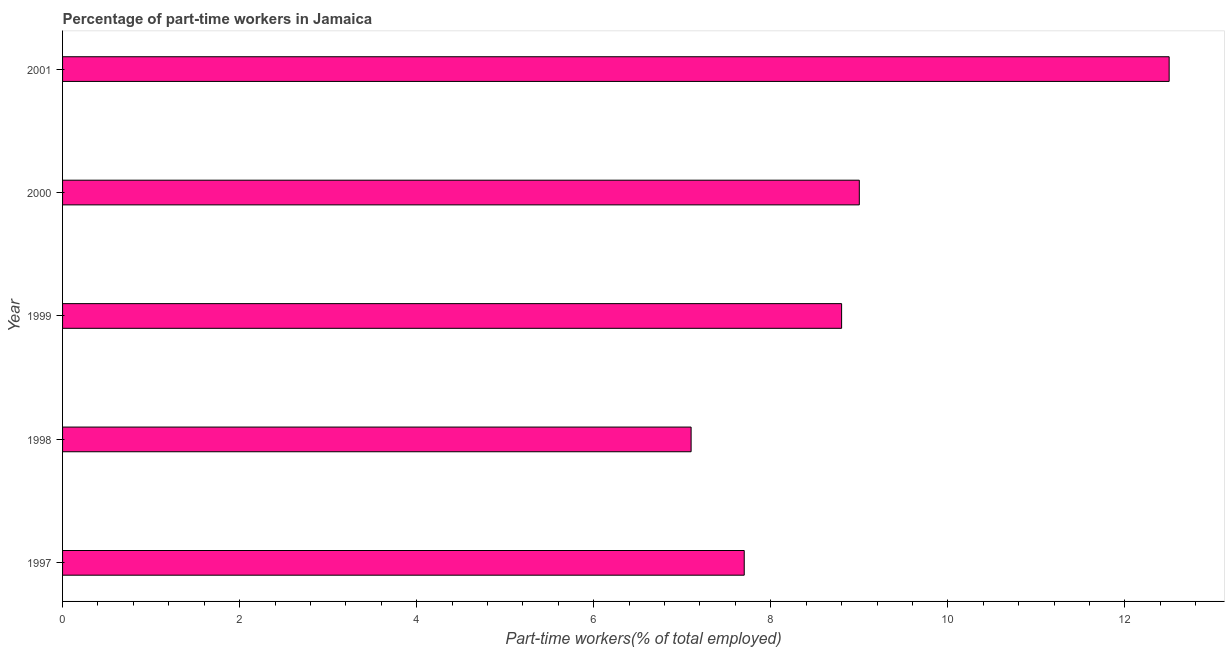Does the graph contain grids?
Your answer should be very brief. No. What is the title of the graph?
Make the answer very short. Percentage of part-time workers in Jamaica. What is the label or title of the X-axis?
Offer a terse response. Part-time workers(% of total employed). What is the label or title of the Y-axis?
Your answer should be very brief. Year. What is the percentage of part-time workers in 1998?
Give a very brief answer. 7.1. Across all years, what is the maximum percentage of part-time workers?
Offer a very short reply. 12.5. Across all years, what is the minimum percentage of part-time workers?
Ensure brevity in your answer.  7.1. In which year was the percentage of part-time workers minimum?
Offer a terse response. 1998. What is the sum of the percentage of part-time workers?
Provide a succinct answer. 45.1. What is the average percentage of part-time workers per year?
Your answer should be compact. 9.02. What is the median percentage of part-time workers?
Offer a very short reply. 8.8. Do a majority of the years between 2000 and 2001 (inclusive) have percentage of part-time workers greater than 4 %?
Offer a terse response. Yes. What is the ratio of the percentage of part-time workers in 1997 to that in 2001?
Ensure brevity in your answer.  0.62. What is the difference between the highest and the lowest percentage of part-time workers?
Provide a succinct answer. 5.4. Are all the bars in the graph horizontal?
Your response must be concise. Yes. What is the Part-time workers(% of total employed) in 1997?
Keep it short and to the point. 7.7. What is the Part-time workers(% of total employed) in 1998?
Offer a terse response. 7.1. What is the Part-time workers(% of total employed) of 1999?
Keep it short and to the point. 8.8. What is the Part-time workers(% of total employed) in 2000?
Give a very brief answer. 9. What is the Part-time workers(% of total employed) in 2001?
Your response must be concise. 12.5. What is the difference between the Part-time workers(% of total employed) in 1997 and 1998?
Provide a short and direct response. 0.6. What is the difference between the Part-time workers(% of total employed) in 1997 and 2000?
Make the answer very short. -1.3. What is the difference between the Part-time workers(% of total employed) in 1998 and 1999?
Keep it short and to the point. -1.7. What is the difference between the Part-time workers(% of total employed) in 1998 and 2001?
Provide a succinct answer. -5.4. What is the ratio of the Part-time workers(% of total employed) in 1997 to that in 1998?
Keep it short and to the point. 1.08. What is the ratio of the Part-time workers(% of total employed) in 1997 to that in 2000?
Make the answer very short. 0.86. What is the ratio of the Part-time workers(% of total employed) in 1997 to that in 2001?
Provide a short and direct response. 0.62. What is the ratio of the Part-time workers(% of total employed) in 1998 to that in 1999?
Provide a succinct answer. 0.81. What is the ratio of the Part-time workers(% of total employed) in 1998 to that in 2000?
Your response must be concise. 0.79. What is the ratio of the Part-time workers(% of total employed) in 1998 to that in 2001?
Your answer should be very brief. 0.57. What is the ratio of the Part-time workers(% of total employed) in 1999 to that in 2001?
Provide a succinct answer. 0.7. What is the ratio of the Part-time workers(% of total employed) in 2000 to that in 2001?
Provide a succinct answer. 0.72. 